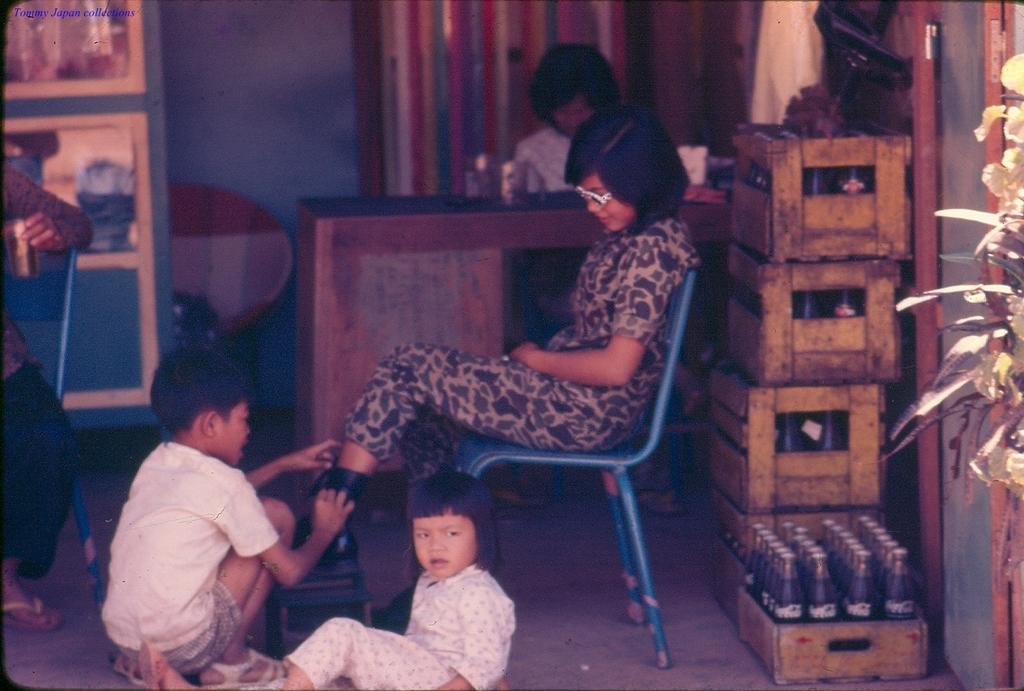What is the person in the image doing? The person is sitting on a chair in the image. Where is the chair located in relation to other objects? The chair is near a desk in the image. What are the children in the image doing? The children are sitting on the ground in the image. What can be seen besides the people and furniture in the image? There are bottles and a plant on the ground in the image. What type of theory is being discussed by the person sitting on the chair? There is no indication in the image that a theory is being discussed; the person is simply sitting on a chair. How many trucks can be seen in the image? There are no trucks present in the image. 